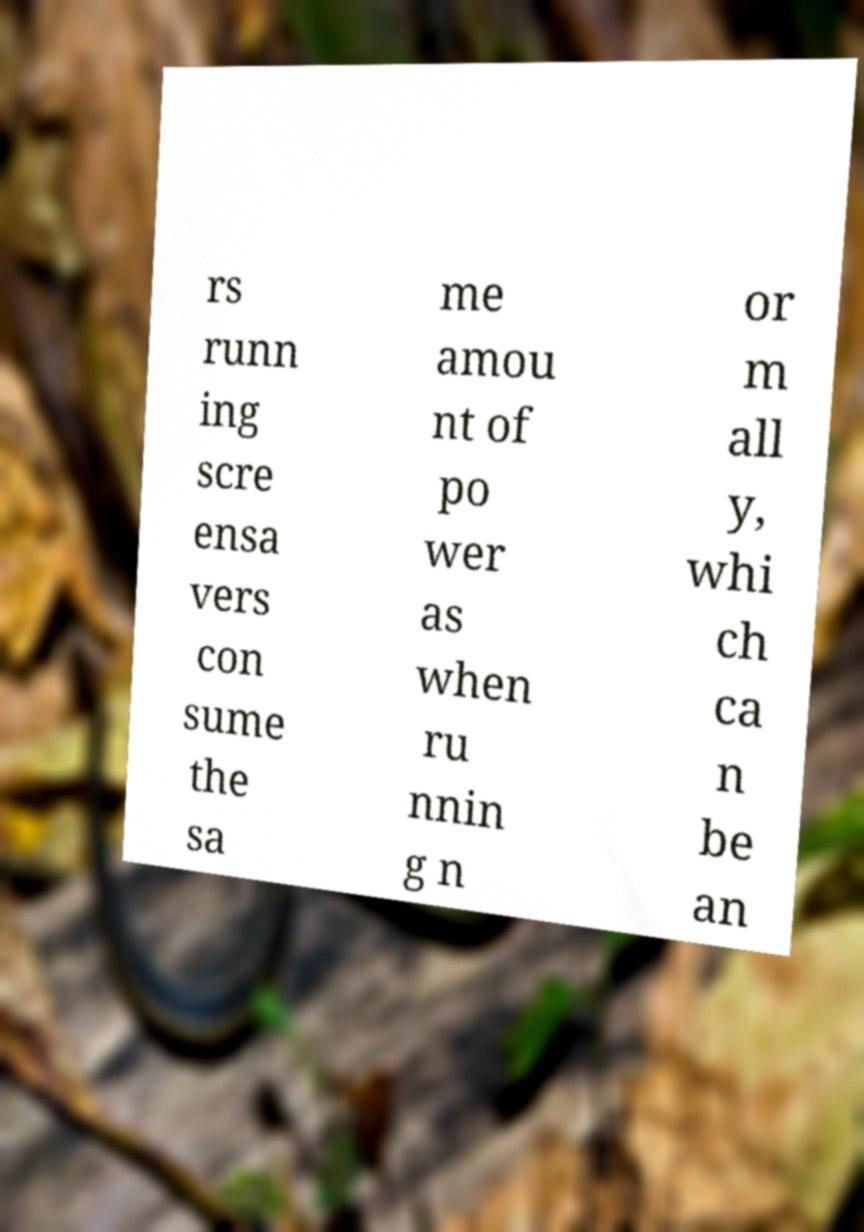I need the written content from this picture converted into text. Can you do that? rs runn ing scre ensa vers con sume the sa me amou nt of po wer as when ru nnin g n or m all y, whi ch ca n be an 